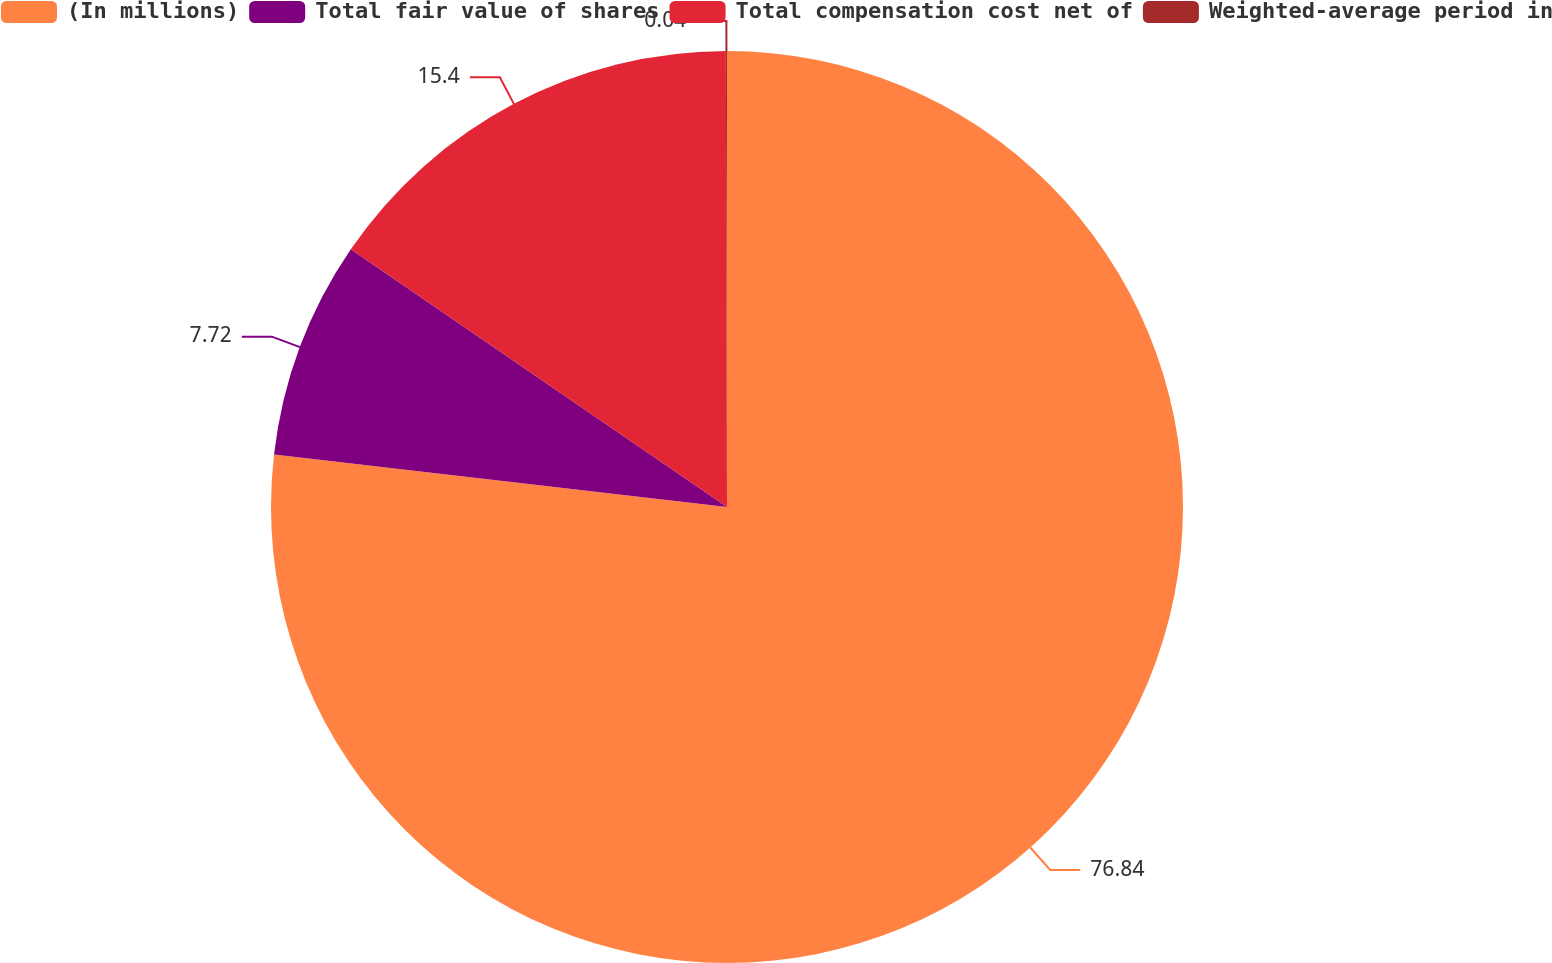<chart> <loc_0><loc_0><loc_500><loc_500><pie_chart><fcel>(In millions)<fcel>Total fair value of shares<fcel>Total compensation cost net of<fcel>Weighted-average period in<nl><fcel>76.84%<fcel>7.72%<fcel>15.4%<fcel>0.04%<nl></chart> 